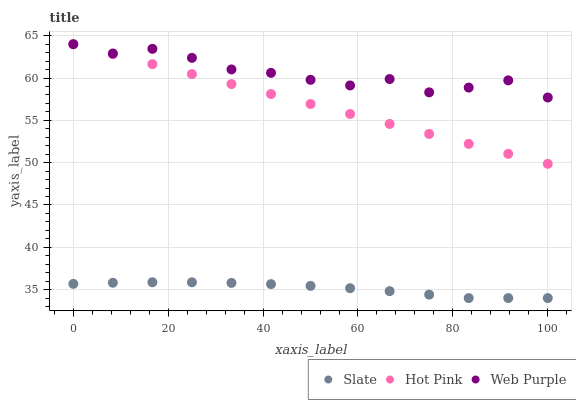Does Slate have the minimum area under the curve?
Answer yes or no. Yes. Does Web Purple have the maximum area under the curve?
Answer yes or no. Yes. Does Hot Pink have the minimum area under the curve?
Answer yes or no. No. Does Hot Pink have the maximum area under the curve?
Answer yes or no. No. Is Hot Pink the smoothest?
Answer yes or no. Yes. Is Web Purple the roughest?
Answer yes or no. Yes. Is Web Purple the smoothest?
Answer yes or no. No. Is Hot Pink the roughest?
Answer yes or no. No. Does Slate have the lowest value?
Answer yes or no. Yes. Does Hot Pink have the lowest value?
Answer yes or no. No. Does Web Purple have the highest value?
Answer yes or no. Yes. Is Slate less than Hot Pink?
Answer yes or no. Yes. Is Hot Pink greater than Slate?
Answer yes or no. Yes. Does Hot Pink intersect Web Purple?
Answer yes or no. Yes. Is Hot Pink less than Web Purple?
Answer yes or no. No. Is Hot Pink greater than Web Purple?
Answer yes or no. No. Does Slate intersect Hot Pink?
Answer yes or no. No. 